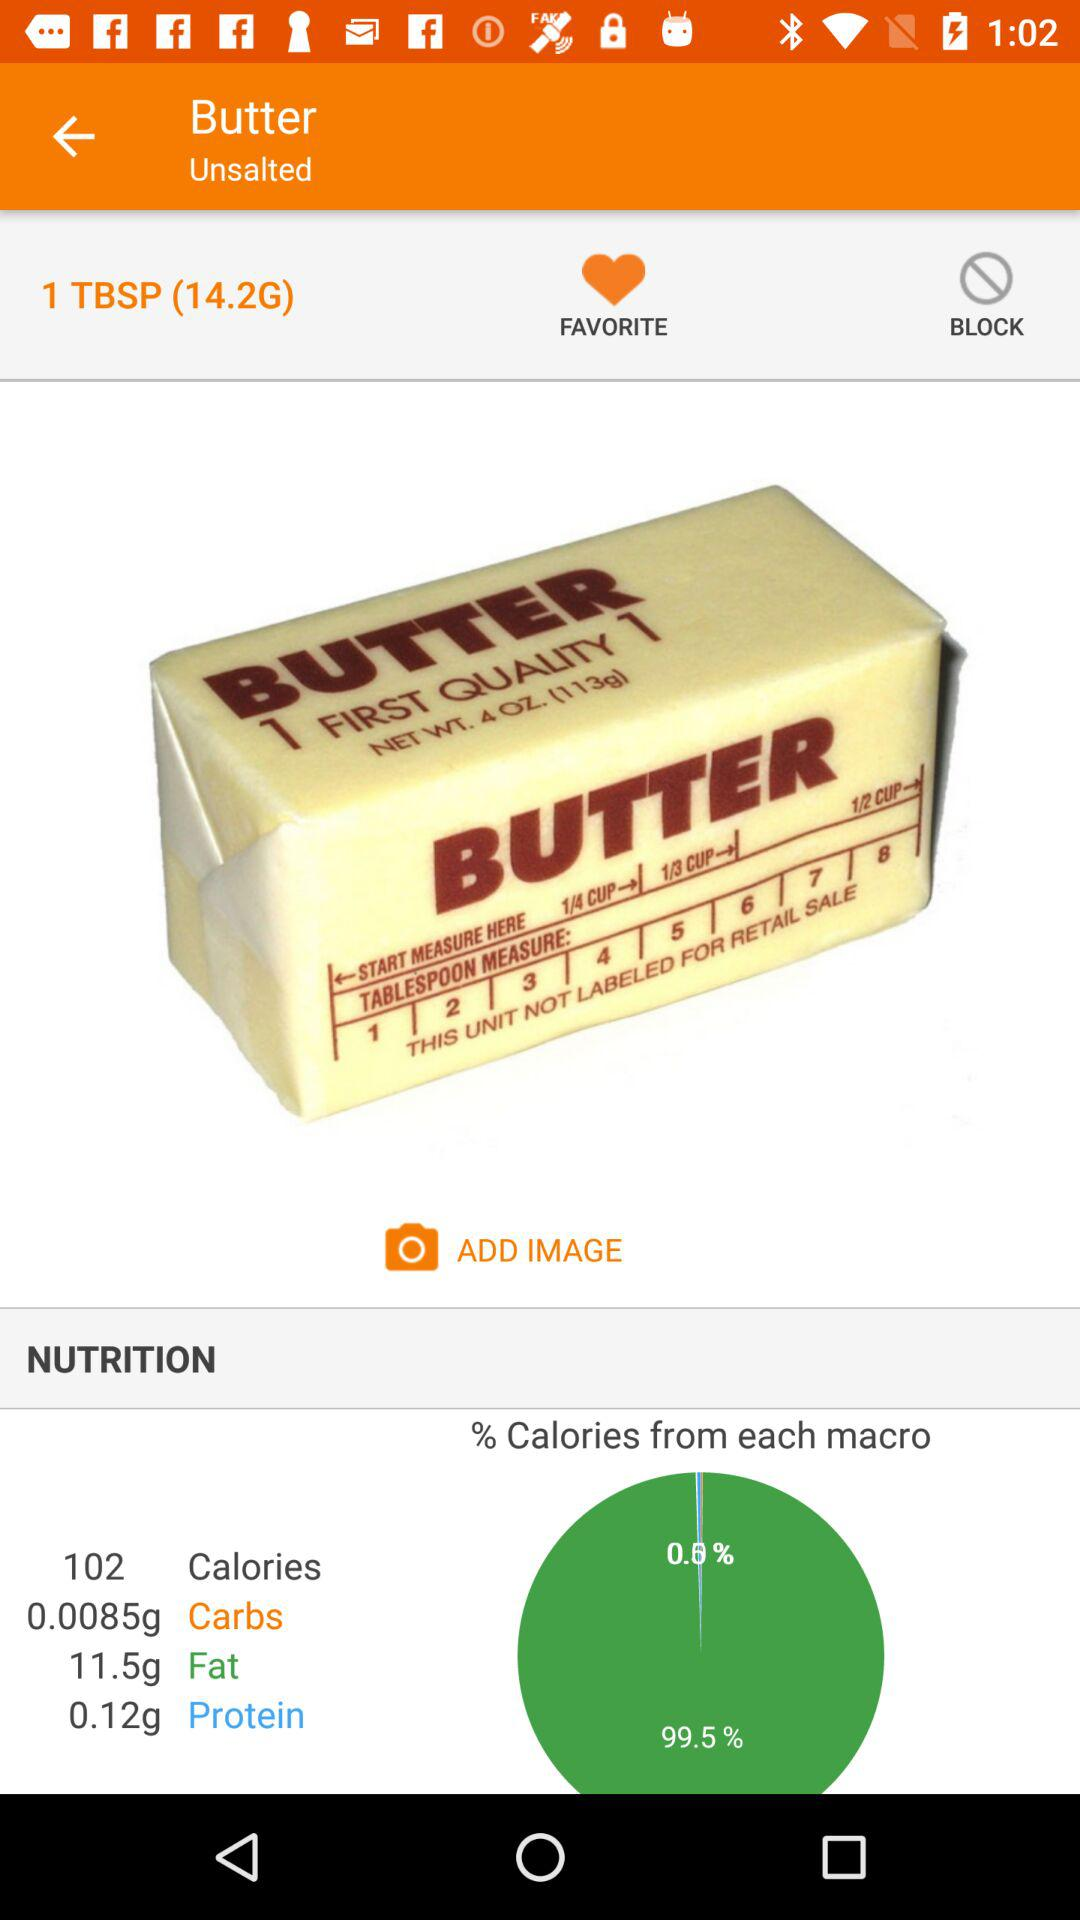Butter is added to which state?
When the provided information is insufficient, respond with <no answer>. <no answer> 